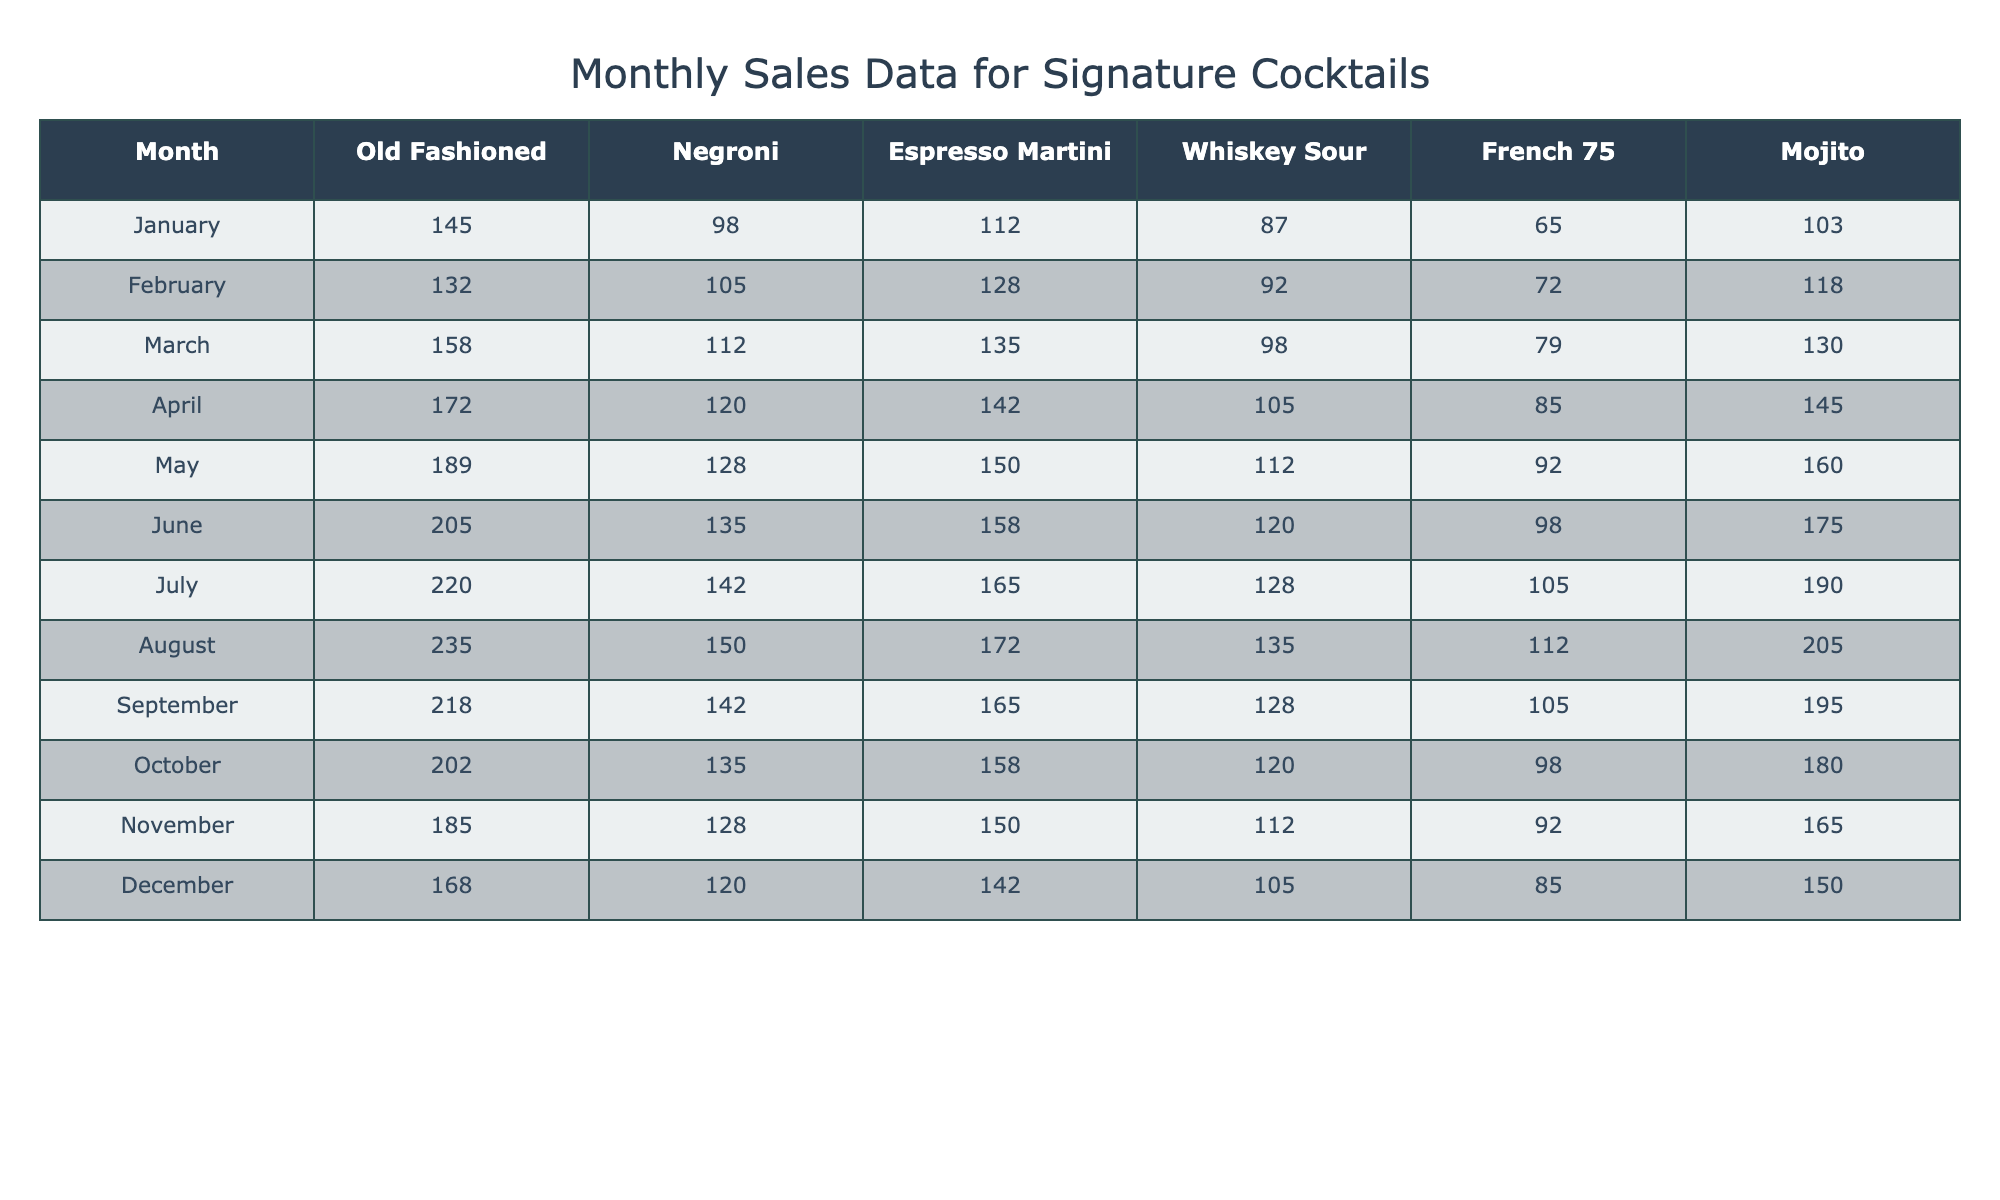What is the highest sales figure for the Old Fashioned cocktail? By examining the table, the highest sales number for the Old Fashioned appears in July with 220 sales.
Answer: 220 Which month had the lowest sales for the Mojito? Looking through the table, the lowest sales for the Mojito occurred in January, where only 103 sales were reported.
Answer: January What is the average sales figure for the Negroni cocktail over the year? The Negroni sales figures are: 98, 105, 112, 120, 128, 135, 142, 150, 142, 135, 128, 120. The average is calculated as (98 + 105 + 112 + 120 + 128 + 135 + 142 + 150 + 142 + 135 + 128 + 120) / 12 = 123.25.
Answer: 123.25 In which month did Espresso Martini have its peak sales? By scanning the table for the highest value in the Espresso Martini row, we find that March has the peak sales of 135.
Answer: March Was there any month where the sales of Whiskey Sour exceeded 130? Checking the table, we see that both July (128) and August (135) have sales figures above 130. Thus, there were months where sales exceeded this value.
Answer: Yes How many total sales were there for French 75 across all months? To find the total sales, we sum the monthly values for French 75: 65 + 72 + 79 + 85 + 92 + 98 + 105 + 112 + 105 + 98 + 92 + 85 = 1127.
Answer: 1127 Compare the total sales for Mojito and Negroni, which one had higher sales throughout the year? The total for Mojito is calculated as 103 + 118 + 130 + 145 + 160 + 175 + 190 + 205 + 195 + 180 + 165 + 150 = 1851. The total for Negroni is 98 + 105 + 112 + 120 + 128 + 135 + 142 + 150 + 142 + 135 + 128 + 120 = 1342. Since 1851 is greater than 1342, Mojito had higher sales.
Answer: Mojito What is the difference in sales between the highest and lowest month for Old Fashioned? The highest sales were in July with 220, and the lowest sales were in February with 132. The difference is 220 - 132 = 88.
Answer: 88 How do the sales for August compare to the sales for November for Espresso Martini? For August, the sales of Espresso Martini are 172, and for November, they are 150. Comparing the two shows that August has 172 which is higher than November's 150.
Answer: August has higher sales What is the trend in sales for the Whiskey Sour from January to December? Reviewing the table shows that Whiskey Sour sales started at 87 in January, increased to 128 in July, and then fluctuated before ending at 105 in December, indicating an initial increase followed by a slight decline.
Answer: Initial increase then decline 